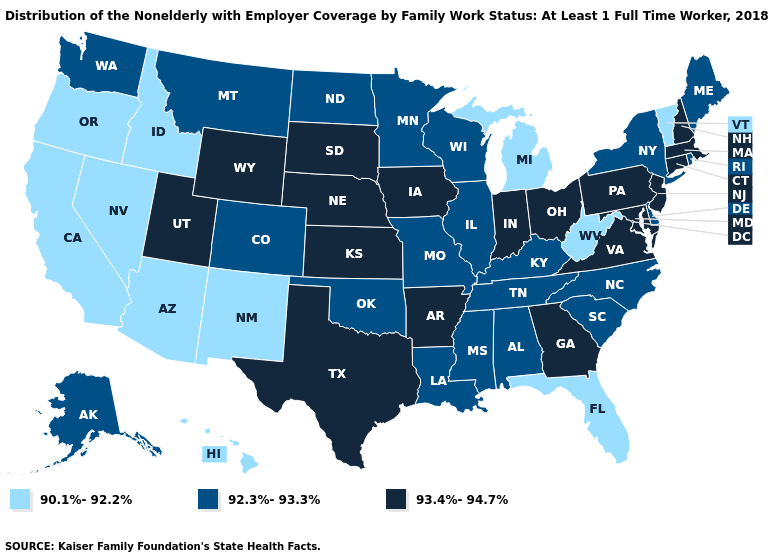Name the states that have a value in the range 90.1%-92.2%?
Concise answer only. Arizona, California, Florida, Hawaii, Idaho, Michigan, Nevada, New Mexico, Oregon, Vermont, West Virginia. Which states hav the highest value in the Northeast?
Write a very short answer. Connecticut, Massachusetts, New Hampshire, New Jersey, Pennsylvania. What is the value of North Dakota?
Answer briefly. 92.3%-93.3%. Does Georgia have the same value as Utah?
Write a very short answer. Yes. Does the map have missing data?
Be succinct. No. Among the states that border New Mexico , which have the highest value?
Concise answer only. Texas, Utah. Does the map have missing data?
Concise answer only. No. Name the states that have a value in the range 93.4%-94.7%?
Give a very brief answer. Arkansas, Connecticut, Georgia, Indiana, Iowa, Kansas, Maryland, Massachusetts, Nebraska, New Hampshire, New Jersey, Ohio, Pennsylvania, South Dakota, Texas, Utah, Virginia, Wyoming. Among the states that border New Jersey , does Pennsylvania have the lowest value?
Write a very short answer. No. What is the value of Washington?
Write a very short answer. 92.3%-93.3%. What is the highest value in the USA?
Keep it brief. 93.4%-94.7%. Among the states that border Missouri , which have the lowest value?
Answer briefly. Illinois, Kentucky, Oklahoma, Tennessee. Which states hav the highest value in the South?
Write a very short answer. Arkansas, Georgia, Maryland, Texas, Virginia. What is the value of West Virginia?
Concise answer only. 90.1%-92.2%. 